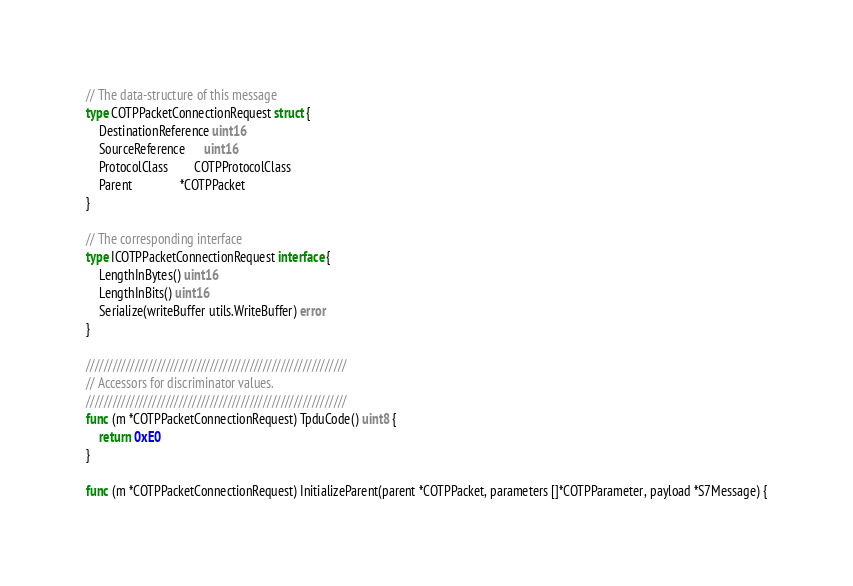Convert code to text. <code><loc_0><loc_0><loc_500><loc_500><_Go_>// The data-structure of this message
type COTPPacketConnectionRequest struct {
	DestinationReference uint16
	SourceReference      uint16
	ProtocolClass        COTPProtocolClass
	Parent               *COTPPacket
}

// The corresponding interface
type ICOTPPacketConnectionRequest interface {
	LengthInBytes() uint16
	LengthInBits() uint16
	Serialize(writeBuffer utils.WriteBuffer) error
}

///////////////////////////////////////////////////////////
// Accessors for discriminator values.
///////////////////////////////////////////////////////////
func (m *COTPPacketConnectionRequest) TpduCode() uint8 {
	return 0xE0
}

func (m *COTPPacketConnectionRequest) InitializeParent(parent *COTPPacket, parameters []*COTPParameter, payload *S7Message) {</code> 